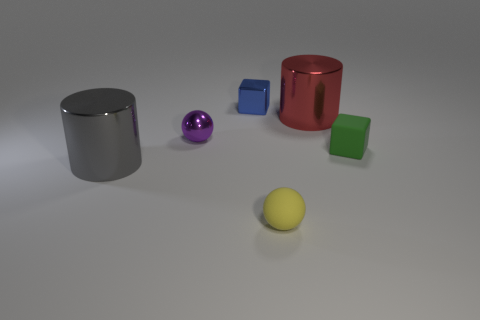What number of purple things are either tiny rubber spheres or tiny objects?
Offer a very short reply. 1. Is the number of big metal cylinders on the right side of the small purple thing less than the number of small rubber objects in front of the green matte thing?
Your response must be concise. No. Are there any metal cylinders of the same size as the gray metallic thing?
Offer a terse response. Yes. There is a matte object that is in front of the rubber cube; does it have the same size as the gray metallic object?
Keep it short and to the point. No. Are there more big green metallic cylinders than blocks?
Provide a succinct answer. No. Is there a large gray thing of the same shape as the tiny yellow thing?
Offer a very short reply. No. What is the shape of the green rubber thing that is in front of the small metal sphere?
Offer a terse response. Cube. What number of metal cylinders are to the right of the small ball in front of the big object that is left of the small purple shiny sphere?
Your response must be concise. 1. How many other objects are there of the same material as the tiny blue block?
Offer a terse response. 3. What is the tiny ball that is in front of the large object left of the tiny sphere on the right side of the tiny metal sphere made of?
Keep it short and to the point. Rubber. 